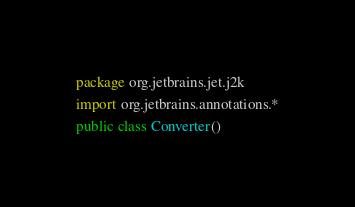Convert code to text. <code><loc_0><loc_0><loc_500><loc_500><_Kotlin_>package org.jetbrains.jet.j2k

import org.jetbrains.annotations.*

public class Converter()</code> 